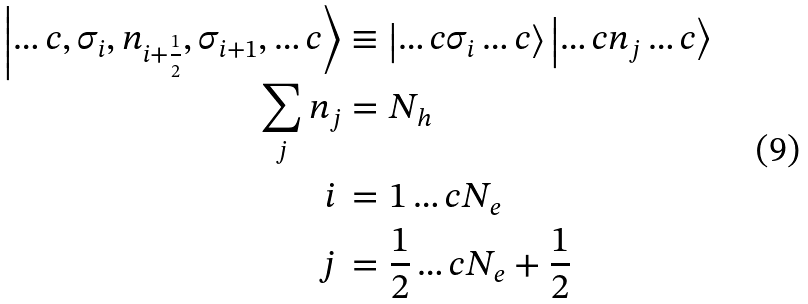<formula> <loc_0><loc_0><loc_500><loc_500>\left | \dots c , \sigma _ { i } , n _ { i + \frac { 1 } { 2 } } , \sigma _ { i + 1 } , \dots c \right > & \equiv \left | \dots c \sigma _ { i } \dots c \right > \left | \dots c n _ { j } \dots c \right > \\ \sum _ { j } { n _ { j } } & = N _ { h } \\ i \, & = 1 \dots c N _ { e } \\ j \, & = \frac { 1 } { 2 } \dots c N _ { e } + \frac { 1 } { 2 }</formula> 